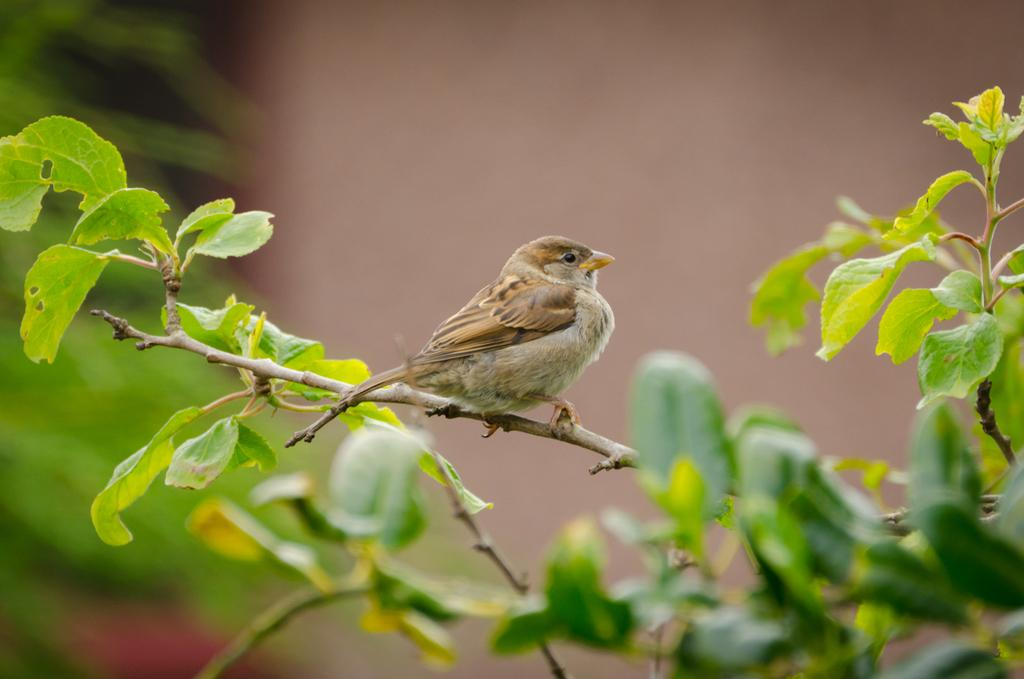What type of bird can be seen in the image? There is a sparrow in the image. Where is the sparrow located in the image? The sparrow is sitting on a stem. What else is present in the image besides the sparrow? There is a plant in the image. Can you describe the background of the image? The background of the image is blurred. What type of toy can be seen in the image? There is no toy present in the image; it features a sparrow sitting on a stem and a plant. Is the image taken in a park? The provided facts do not mention a park, so it cannot be determined from the image. 